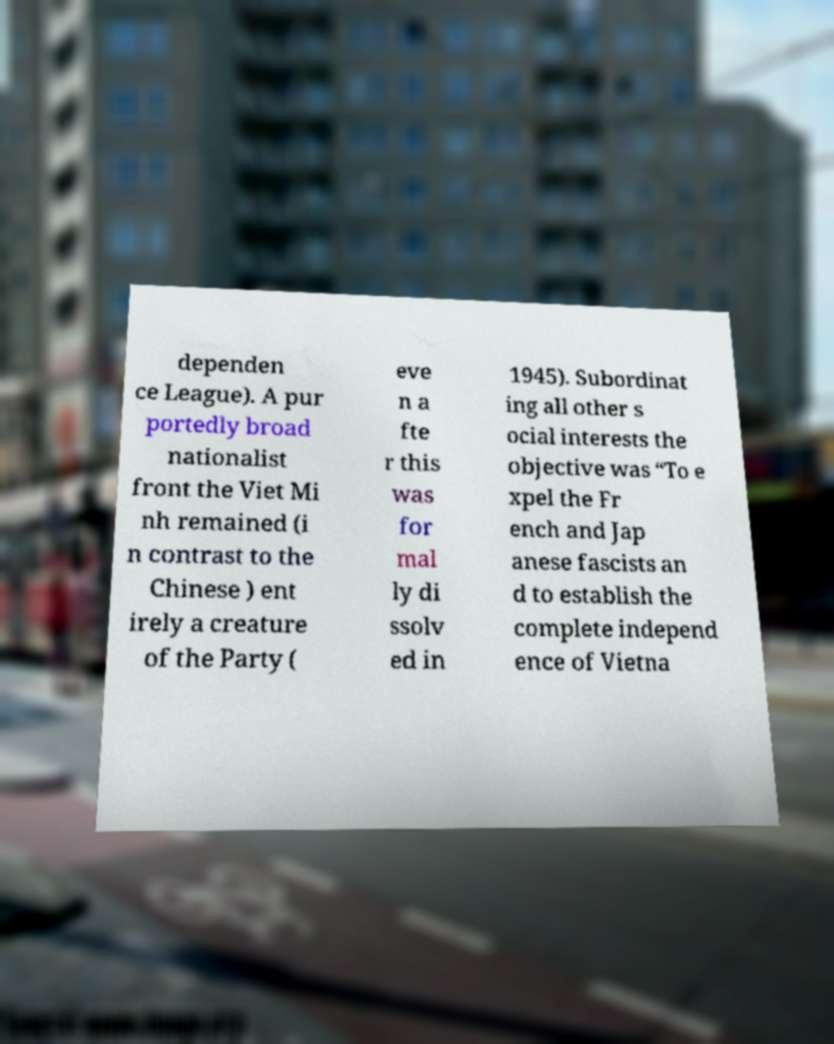Could you extract and type out the text from this image? dependen ce League). A pur portedly broad nationalist front the Viet Mi nh remained (i n contrast to the Chinese ) ent irely a creature of the Party ( eve n a fte r this was for mal ly di ssolv ed in 1945). Subordinat ing all other s ocial interests the objective was “To e xpel the Fr ench and Jap anese fascists an d to establish the complete independ ence of Vietna 